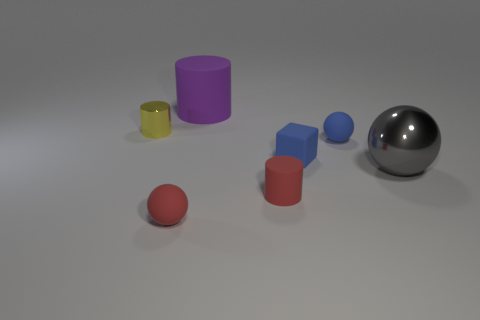Subtract all small balls. How many balls are left? 1 Subtract all cylinders. How many objects are left? 4 Subtract 3 cylinders. How many cylinders are left? 0 Subtract all big blue metallic cylinders. Subtract all metallic cylinders. How many objects are left? 6 Add 6 matte blocks. How many matte blocks are left? 7 Add 7 small spheres. How many small spheres exist? 9 Add 2 small metallic things. How many objects exist? 9 Subtract all red spheres. How many spheres are left? 2 Subtract 0 green balls. How many objects are left? 7 Subtract all gray cylinders. Subtract all purple blocks. How many cylinders are left? 3 